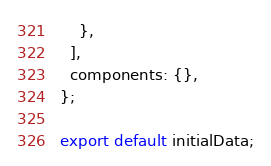Convert code to text. <code><loc_0><loc_0><loc_500><loc_500><_JavaScript_>    },
  ],
  components: {},
};

export default initialData;
</code> 